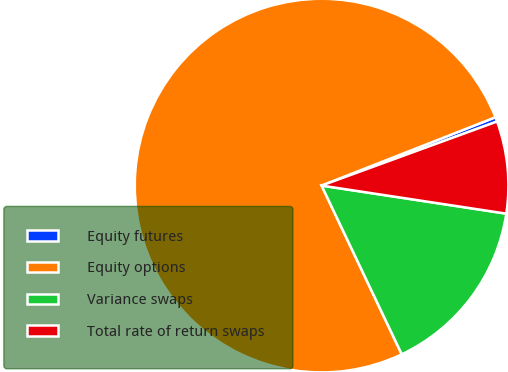Convert chart to OTSL. <chart><loc_0><loc_0><loc_500><loc_500><pie_chart><fcel>Equity futures<fcel>Equity options<fcel>Variance swaps<fcel>Total rate of return swaps<nl><fcel>0.39%<fcel>76.1%<fcel>15.54%<fcel>7.97%<nl></chart> 